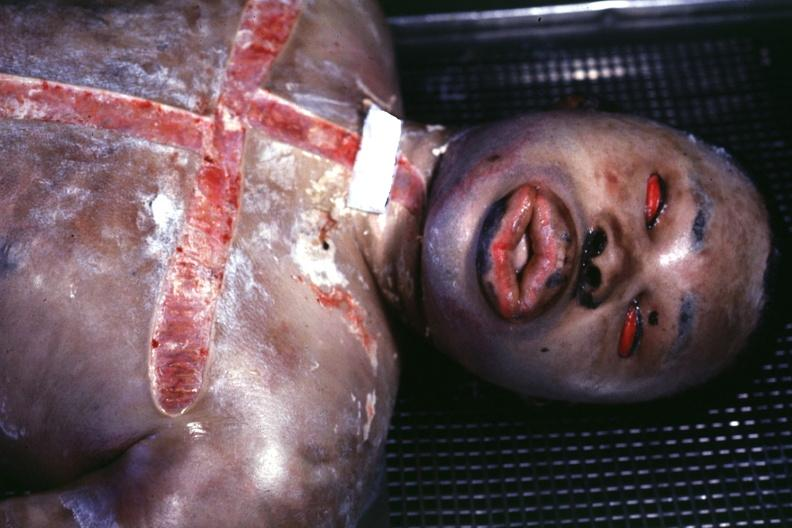how is view of face showing edema?
Answer the question using a single word or phrase. Grotesque 